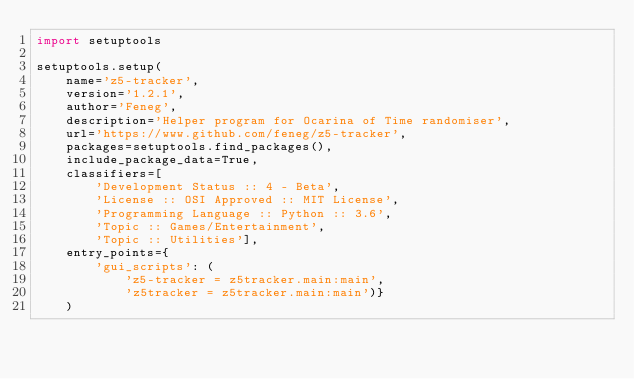Convert code to text. <code><loc_0><loc_0><loc_500><loc_500><_Python_>import setuptools

setuptools.setup(
    name='z5-tracker',
    version='1.2.1',
    author='Feneg',
    description='Helper program for Ocarina of Time randomiser',
    url='https://www.github.com/feneg/z5-tracker',
    packages=setuptools.find_packages(),
    include_package_data=True,
    classifiers=[
        'Development Status :: 4 - Beta',
        'License :: OSI Approved :: MIT License',
        'Programming Language :: Python :: 3.6',
        'Topic :: Games/Entertainment',
        'Topic :: Utilities'],
    entry_points={
        'gui_scripts': (
            'z5-tracker = z5tracker.main:main',
            'z5tracker = z5tracker.main:main')}
    )
</code> 